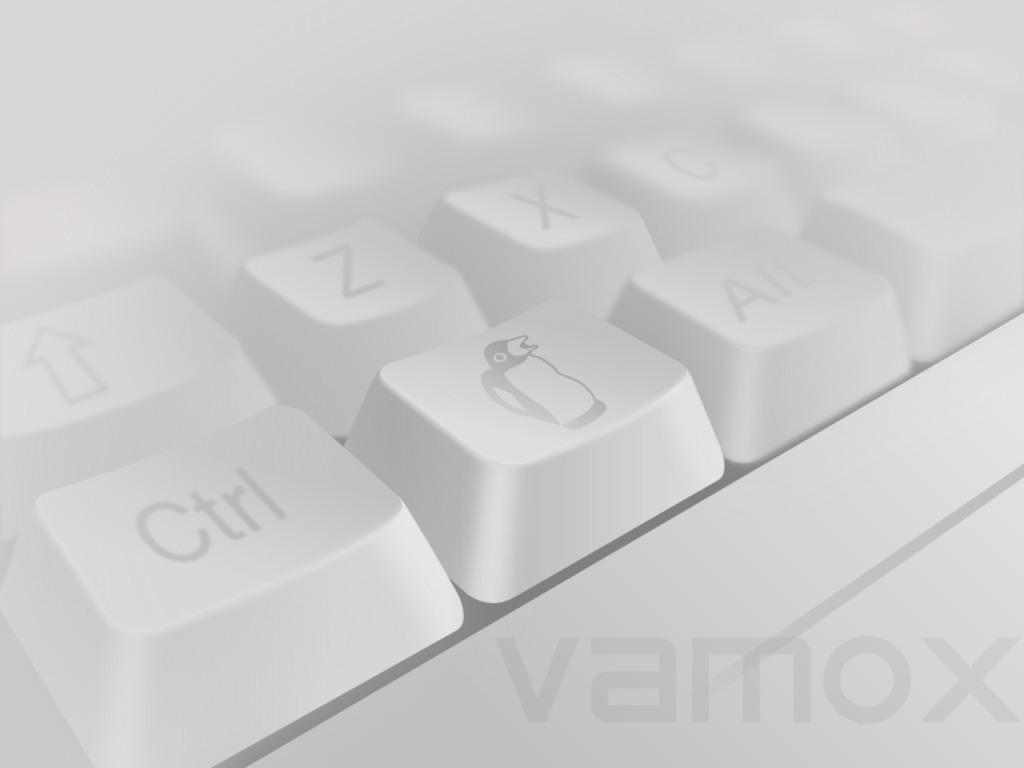What is the main object in the center of the image? There are keys in the center of the image. Is there any text present in the image? Yes, there is some text at the bottom of the image. What type of chair is depicted in the image? There is no chair present in the image; it only features keys and text. What knowledge can be gained from the image? The image does not convey any specific knowledge, as it only contains keys and text. 